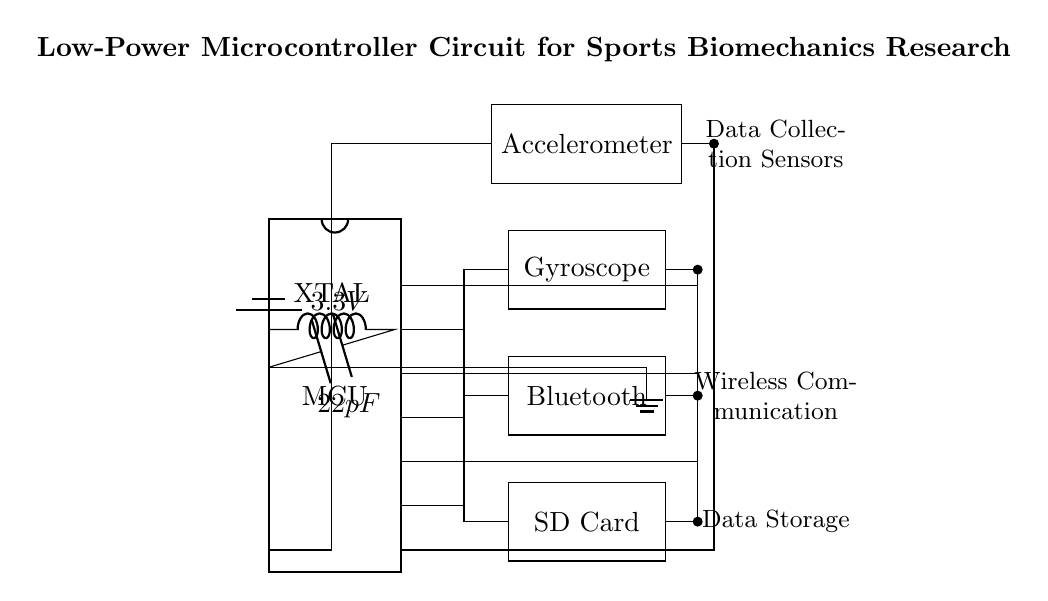What type of microcontroller is shown in the circuit? The component labeled "MCU" is a microcontroller, often referred to as an MCU. It is a common term used in electronics for a compact integrated circuit designed to govern a specific operation in an embedded system.
Answer: microcontroller What is the voltage of the power supply? In the circuit diagram, a battery is supplying power at 3.3V. This is indicated next to the battery component, which connects to the microcontroller.
Answer: 3.3V How many pins does the microcontroller have? The microcontroller in the diagram has 16 pins, as indicated by the "num pins=16" notation in its design representation.
Answer: 16 pins What components are connected to the microcontroller for data collection? The components labeled "Accelerometer" and "Gyroscope" are connected to the microcontroller for data collection purposes. Both sensors provide measurements relevant to biomechanics.
Answer: Accelerometer and Gyroscope What is the purpose of the Bluetooth module in this circuit? The Bluetooth module allows for wireless communication, enabling data transfer from the microcontroller to other devices such as smartphones or computers. This facilitates remote monitoring of the collected data.
Answer: Wireless communication How is data stored in this circuit? The circuit diagram includes an "SD Card" module, which serves as the data storage device. The connection to the microcontroller allows for data collected from the sensors to be saved for later analysis.
Answer: SD Card Which component is used for timing in the microcontroller circuit? A crystal oscillator, represented as "XTAL" in the circuit, is used for timing. It provides a clock signal necessary for the microcontroller to function at the required frequency.
Answer: Crystal oscillator 